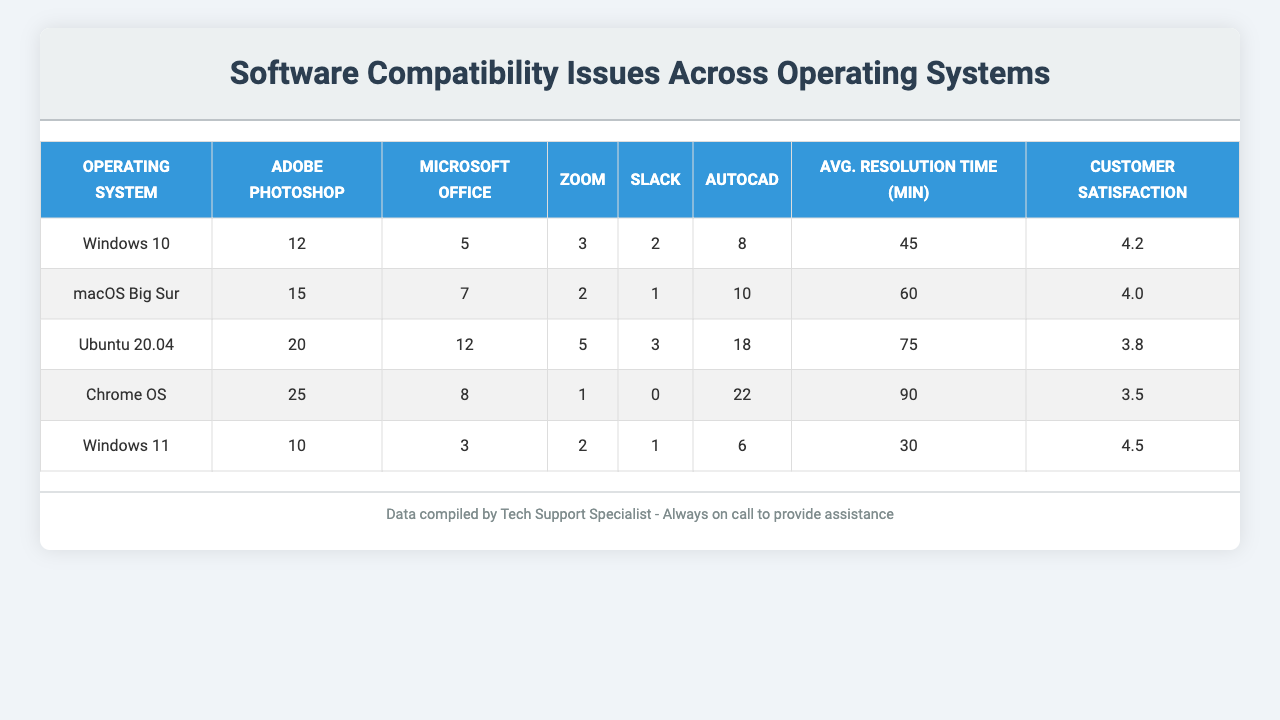What is the highest number of compatibility issues for Adobe Photoshop? Looking at the table, the highest compatibility issues for Adobe Photoshop is found under Chrome OS, which is 25.
Answer: 25 Which operating system has the lowest customer satisfaction rating? By examining the customer satisfaction column, we see that Chrome OS has the lowest rating at 3.5.
Answer: Chrome OS How many compatibility issues are reported for Zoom on Ubuntu 20.04? The table indicates that there are 5 compatibility issues reported for Zoom on Ubuntu 20.04.
Answer: 5 What is the average resolution time for Windows 11? The table states that the average resolution time for Windows 11 is 30 minutes.
Answer: 30 Which software application has the most reported compatibility issues on macOS Big Sur? The most reported compatibility issue on macOS Big Sur is with Adobe Photoshop, which has 15 issues.
Answer: Adobe Photoshop What is the total number of compatibility issues for AutoCAD across all operating systems? Adding the issues for AutoCAD: 8 (Windows 10) + 10 (macOS Big Sur) + 18 (Ubuntu 20.04) + 22 (Chrome OS) + 6 (Windows 11) gives 64 total compatibility issues.
Answer: 64 Is there a software application that has zero compatibility issues on any operating system? Yes, Slack has zero reported compatibility issues on Chrome OS.
Answer: Yes Which operating system has a higher average resolution time, Windows 10 or Windows 11? Windows 10 has an average resolution time of 45 minutes, while Windows 11 has 30 minutes; therefore, Windows 10 has a higher resolution time.
Answer: Windows 10 Find the difference in customer satisfaction ratings between Ubuntu 20.04 and macOS Big Sur. The customer satisfaction rating for Ubuntu 20.04 is 3.8 and for macOS Big Sur is 4.0. The difference is 4.0 - 3.8 = 0.2.
Answer: 0.2 If we consider all types of compatibility issues reported for Windows 10 and compare it to the total for Chrome OS, which is higher? Calculating Windows 10 issues: 12 + 5 + 3 + 2 + 8 = 30. For Chrome OS, the total is 25 + 8 + 1 + 0 + 22 = 56. Since 56 > 30, Chrome OS has more issues.
Answer: Chrome OS 